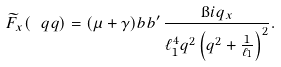Convert formula to latex. <formula><loc_0><loc_0><loc_500><loc_500>\widetilde { F } _ { x } ( \ q q ) & = ( \mu + \gamma ) b b ^ { \prime } \, \frac { \i i q _ { x } } { \ell _ { 1 } ^ { 4 } q ^ { 2 } \left ( q ^ { 2 } + \frac { 1 } { \ell _ { 1 } } \right ) ^ { 2 } } .</formula> 